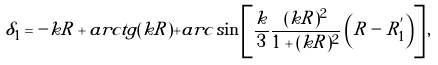Convert formula to latex. <formula><loc_0><loc_0><loc_500><loc_500>\delta _ { 1 } = - k R + { a r c t g } ( k R ) + { a r c \sin } \left [ \frac { k } { 3 } \frac { ( k R ) ^ { 2 } } { 1 + ( k R ) ^ { 2 } } \left ( R - R ^ { ^ { \prime } } _ { 1 } \right ) \right ] ,</formula> 